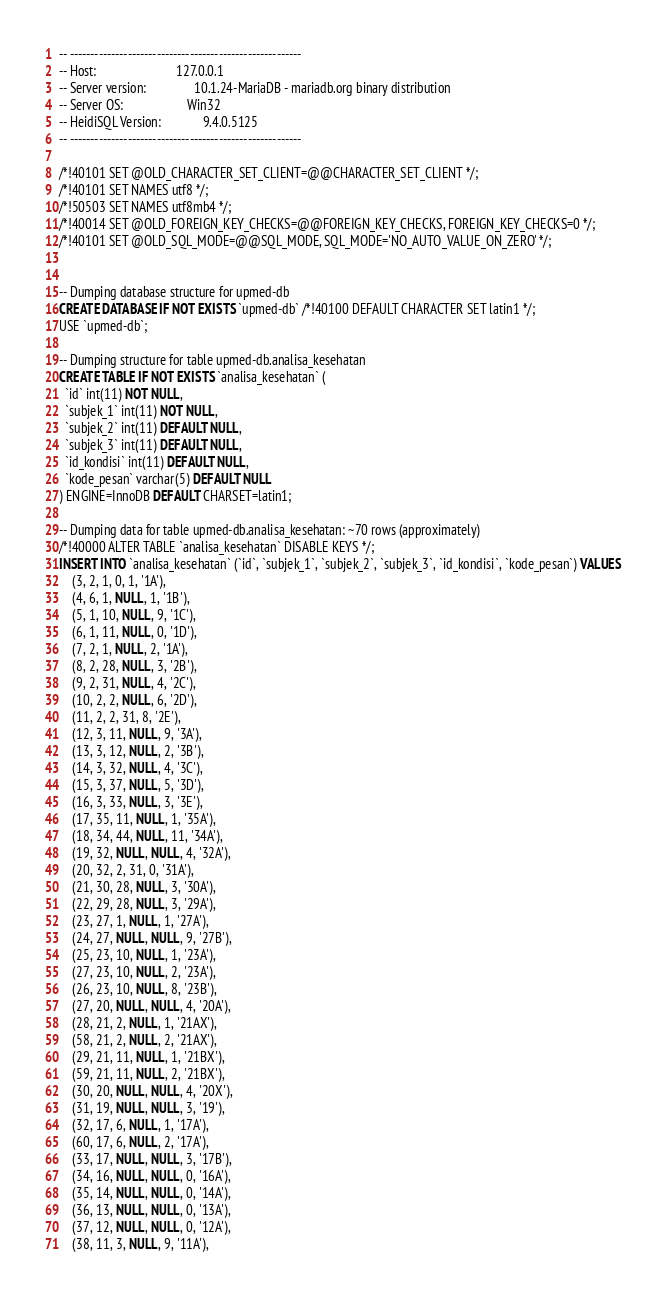<code> <loc_0><loc_0><loc_500><loc_500><_SQL_>-- --------------------------------------------------------
-- Host:                         127.0.0.1
-- Server version:               10.1.24-MariaDB - mariadb.org binary distribution
-- Server OS:                    Win32
-- HeidiSQL Version:             9.4.0.5125
-- --------------------------------------------------------

/*!40101 SET @OLD_CHARACTER_SET_CLIENT=@@CHARACTER_SET_CLIENT */;
/*!40101 SET NAMES utf8 */;
/*!50503 SET NAMES utf8mb4 */;
/*!40014 SET @OLD_FOREIGN_KEY_CHECKS=@@FOREIGN_KEY_CHECKS, FOREIGN_KEY_CHECKS=0 */;
/*!40101 SET @OLD_SQL_MODE=@@SQL_MODE, SQL_MODE='NO_AUTO_VALUE_ON_ZERO' */;


-- Dumping database structure for upmed-db
CREATE DATABASE IF NOT EXISTS `upmed-db` /*!40100 DEFAULT CHARACTER SET latin1 */;
USE `upmed-db`;

-- Dumping structure for table upmed-db.analisa_kesehatan
CREATE TABLE IF NOT EXISTS `analisa_kesehatan` (
  `id` int(11) NOT NULL,
  `subjek_1` int(11) NOT NULL,
  `subjek_2` int(11) DEFAULT NULL,
  `subjek_3` int(11) DEFAULT NULL,
  `id_kondisi` int(11) DEFAULT NULL,
  `kode_pesan` varchar(5) DEFAULT NULL
) ENGINE=InnoDB DEFAULT CHARSET=latin1;

-- Dumping data for table upmed-db.analisa_kesehatan: ~70 rows (approximately)
/*!40000 ALTER TABLE `analisa_kesehatan` DISABLE KEYS */;
INSERT INTO `analisa_kesehatan` (`id`, `subjek_1`, `subjek_2`, `subjek_3`, `id_kondisi`, `kode_pesan`) VALUES
	(3, 2, 1, 0, 1, '1A'),
	(4, 6, 1, NULL, 1, '1B'),
	(5, 1, 10, NULL, 9, '1C'),
	(6, 1, 11, NULL, 0, '1D'),
	(7, 2, 1, NULL, 2, '1A'),
	(8, 2, 28, NULL, 3, '2B'),
	(9, 2, 31, NULL, 4, '2C'),
	(10, 2, 2, NULL, 6, '2D'),
	(11, 2, 2, 31, 8, '2E'),
	(12, 3, 11, NULL, 9, '3A'),
	(13, 3, 12, NULL, 2, '3B'),
	(14, 3, 32, NULL, 4, '3C'),
	(15, 3, 37, NULL, 5, '3D'),
	(16, 3, 33, NULL, 3, '3E'),
	(17, 35, 11, NULL, 1, '35A'),
	(18, 34, 44, NULL, 11, '34A'),
	(19, 32, NULL, NULL, 4, '32A'),
	(20, 32, 2, 31, 0, '31A'),
	(21, 30, 28, NULL, 3, '30A'),
	(22, 29, 28, NULL, 3, '29A'),
	(23, 27, 1, NULL, 1, '27A'),
	(24, 27, NULL, NULL, 9, '27B'),
	(25, 23, 10, NULL, 1, '23A'),
	(27, 23, 10, NULL, 2, '23A'),
	(26, 23, 10, NULL, 8, '23B'),
	(27, 20, NULL, NULL, 4, '20A'),
	(28, 21, 2, NULL, 1, '21AX'),
	(58, 21, 2, NULL, 2, '21AX'),
	(29, 21, 11, NULL, 1, '21BX'),
	(59, 21, 11, NULL, 2, '21BX'),
	(30, 20, NULL, NULL, 4, '20X'),
	(31, 19, NULL, NULL, 3, '19'),
	(32, 17, 6, NULL, 1, '17A'),
	(60, 17, 6, NULL, 2, '17A'),
	(33, 17, NULL, NULL, 3, '17B'),
	(34, 16, NULL, NULL, 0, '16A'),
	(35, 14, NULL, NULL, 0, '14A'),
	(36, 13, NULL, NULL, 0, '13A'),
	(37, 12, NULL, NULL, 0, '12A'),
	(38, 11, 3, NULL, 9, '11A'),</code> 